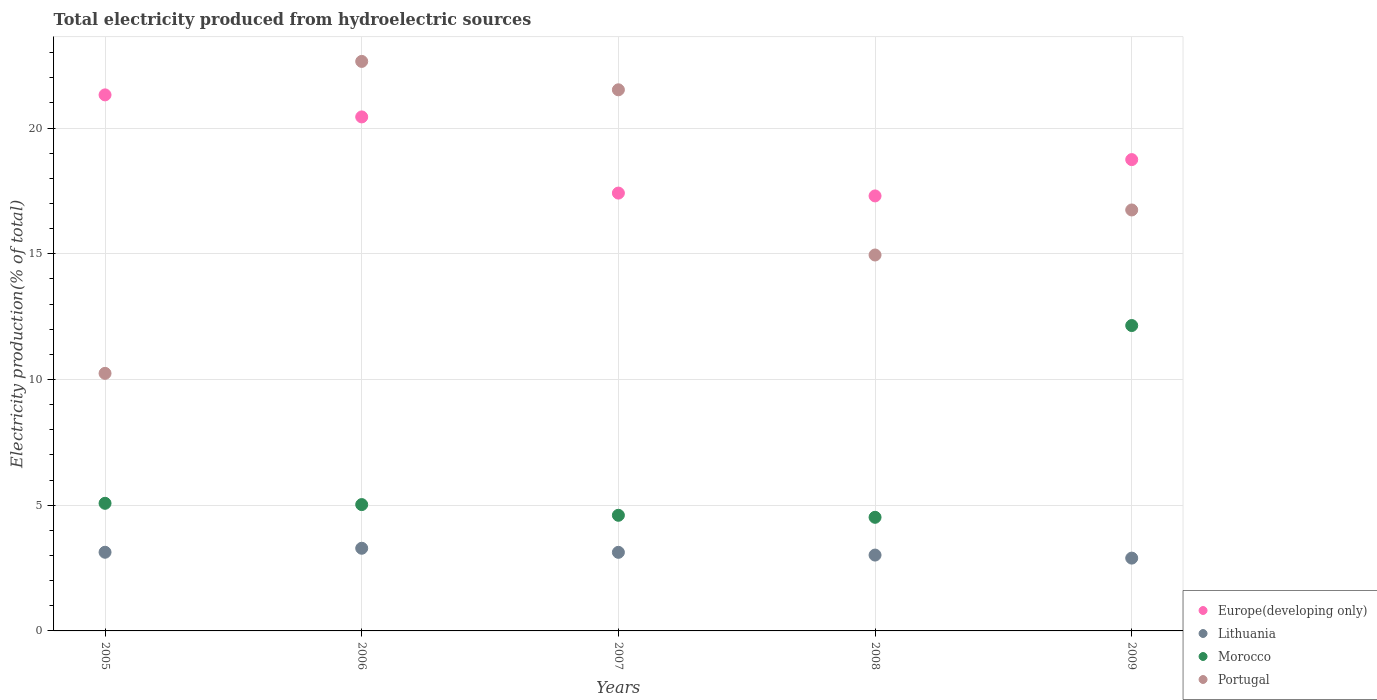How many different coloured dotlines are there?
Offer a very short reply. 4. What is the total electricity produced in Morocco in 2007?
Make the answer very short. 4.6. Across all years, what is the maximum total electricity produced in Portugal?
Give a very brief answer. 22.65. Across all years, what is the minimum total electricity produced in Lithuania?
Ensure brevity in your answer.  2.9. In which year was the total electricity produced in Europe(developing only) maximum?
Provide a short and direct response. 2005. What is the total total electricity produced in Lithuania in the graph?
Keep it short and to the point. 15.45. What is the difference between the total electricity produced in Europe(developing only) in 2007 and that in 2009?
Your answer should be very brief. -1.33. What is the difference between the total electricity produced in Portugal in 2006 and the total electricity produced in Europe(developing only) in 2005?
Keep it short and to the point. 1.33. What is the average total electricity produced in Portugal per year?
Offer a terse response. 17.22. In the year 2005, what is the difference between the total electricity produced in Lithuania and total electricity produced in Morocco?
Ensure brevity in your answer.  -1.95. In how many years, is the total electricity produced in Morocco greater than 3 %?
Your answer should be very brief. 5. What is the ratio of the total electricity produced in Morocco in 2005 to that in 2006?
Your answer should be compact. 1.01. Is the total electricity produced in Lithuania in 2005 less than that in 2009?
Your answer should be compact. No. Is the difference between the total electricity produced in Lithuania in 2005 and 2008 greater than the difference between the total electricity produced in Morocco in 2005 and 2008?
Ensure brevity in your answer.  No. What is the difference between the highest and the second highest total electricity produced in Europe(developing only)?
Your response must be concise. 0.88. What is the difference between the highest and the lowest total electricity produced in Lithuania?
Ensure brevity in your answer.  0.39. In how many years, is the total electricity produced in Morocco greater than the average total electricity produced in Morocco taken over all years?
Give a very brief answer. 1. Does the total electricity produced in Europe(developing only) monotonically increase over the years?
Keep it short and to the point. No. Is the total electricity produced in Portugal strictly greater than the total electricity produced in Europe(developing only) over the years?
Make the answer very short. No. How many dotlines are there?
Ensure brevity in your answer.  4. How many years are there in the graph?
Provide a short and direct response. 5. What is the difference between two consecutive major ticks on the Y-axis?
Offer a very short reply. 5. Where does the legend appear in the graph?
Provide a succinct answer. Bottom right. What is the title of the graph?
Give a very brief answer. Total electricity produced from hydroelectric sources. Does "Bhutan" appear as one of the legend labels in the graph?
Provide a short and direct response. No. What is the label or title of the X-axis?
Offer a very short reply. Years. What is the label or title of the Y-axis?
Your response must be concise. Electricity production(% of total). What is the Electricity production(% of total) of Europe(developing only) in 2005?
Provide a succinct answer. 21.32. What is the Electricity production(% of total) of Lithuania in 2005?
Ensure brevity in your answer.  3.13. What is the Electricity production(% of total) of Morocco in 2005?
Ensure brevity in your answer.  5.08. What is the Electricity production(% of total) of Portugal in 2005?
Provide a succinct answer. 10.24. What is the Electricity production(% of total) of Europe(developing only) in 2006?
Give a very brief answer. 20.44. What is the Electricity production(% of total) of Lithuania in 2006?
Provide a short and direct response. 3.29. What is the Electricity production(% of total) of Morocco in 2006?
Your answer should be compact. 5.02. What is the Electricity production(% of total) of Portugal in 2006?
Keep it short and to the point. 22.65. What is the Electricity production(% of total) in Europe(developing only) in 2007?
Ensure brevity in your answer.  17.41. What is the Electricity production(% of total) in Lithuania in 2007?
Offer a very short reply. 3.13. What is the Electricity production(% of total) in Morocco in 2007?
Keep it short and to the point. 4.6. What is the Electricity production(% of total) in Portugal in 2007?
Your answer should be compact. 21.52. What is the Electricity production(% of total) of Europe(developing only) in 2008?
Keep it short and to the point. 17.3. What is the Electricity production(% of total) of Lithuania in 2008?
Your response must be concise. 3.02. What is the Electricity production(% of total) in Morocco in 2008?
Provide a succinct answer. 4.52. What is the Electricity production(% of total) of Portugal in 2008?
Offer a very short reply. 14.95. What is the Electricity production(% of total) in Europe(developing only) in 2009?
Your answer should be very brief. 18.74. What is the Electricity production(% of total) of Lithuania in 2009?
Keep it short and to the point. 2.9. What is the Electricity production(% of total) of Morocco in 2009?
Offer a terse response. 12.14. What is the Electricity production(% of total) of Portugal in 2009?
Offer a terse response. 16.74. Across all years, what is the maximum Electricity production(% of total) in Europe(developing only)?
Provide a succinct answer. 21.32. Across all years, what is the maximum Electricity production(% of total) of Lithuania?
Give a very brief answer. 3.29. Across all years, what is the maximum Electricity production(% of total) of Morocco?
Your response must be concise. 12.14. Across all years, what is the maximum Electricity production(% of total) of Portugal?
Keep it short and to the point. 22.65. Across all years, what is the minimum Electricity production(% of total) of Europe(developing only)?
Ensure brevity in your answer.  17.3. Across all years, what is the minimum Electricity production(% of total) of Lithuania?
Your answer should be compact. 2.9. Across all years, what is the minimum Electricity production(% of total) in Morocco?
Provide a succinct answer. 4.52. Across all years, what is the minimum Electricity production(% of total) in Portugal?
Your response must be concise. 10.24. What is the total Electricity production(% of total) in Europe(developing only) in the graph?
Offer a very short reply. 95.22. What is the total Electricity production(% of total) in Lithuania in the graph?
Your answer should be very brief. 15.45. What is the total Electricity production(% of total) in Morocco in the graph?
Provide a short and direct response. 31.36. What is the total Electricity production(% of total) of Portugal in the graph?
Make the answer very short. 86.1. What is the difference between the Electricity production(% of total) of Europe(developing only) in 2005 and that in 2006?
Provide a succinct answer. 0.88. What is the difference between the Electricity production(% of total) of Lithuania in 2005 and that in 2006?
Make the answer very short. -0.16. What is the difference between the Electricity production(% of total) in Morocco in 2005 and that in 2006?
Your answer should be very brief. 0.05. What is the difference between the Electricity production(% of total) in Portugal in 2005 and that in 2006?
Offer a very short reply. -12.41. What is the difference between the Electricity production(% of total) of Europe(developing only) in 2005 and that in 2007?
Offer a terse response. 3.91. What is the difference between the Electricity production(% of total) in Lithuania in 2005 and that in 2007?
Make the answer very short. 0. What is the difference between the Electricity production(% of total) in Morocco in 2005 and that in 2007?
Provide a short and direct response. 0.48. What is the difference between the Electricity production(% of total) in Portugal in 2005 and that in 2007?
Give a very brief answer. -11.28. What is the difference between the Electricity production(% of total) of Europe(developing only) in 2005 and that in 2008?
Ensure brevity in your answer.  4.02. What is the difference between the Electricity production(% of total) of Lithuania in 2005 and that in 2008?
Give a very brief answer. 0.11. What is the difference between the Electricity production(% of total) in Morocco in 2005 and that in 2008?
Provide a short and direct response. 0.56. What is the difference between the Electricity production(% of total) of Portugal in 2005 and that in 2008?
Ensure brevity in your answer.  -4.71. What is the difference between the Electricity production(% of total) of Europe(developing only) in 2005 and that in 2009?
Provide a succinct answer. 2.57. What is the difference between the Electricity production(% of total) in Lithuania in 2005 and that in 2009?
Keep it short and to the point. 0.23. What is the difference between the Electricity production(% of total) of Morocco in 2005 and that in 2009?
Offer a very short reply. -7.07. What is the difference between the Electricity production(% of total) in Portugal in 2005 and that in 2009?
Ensure brevity in your answer.  -6.5. What is the difference between the Electricity production(% of total) of Europe(developing only) in 2006 and that in 2007?
Offer a terse response. 3.03. What is the difference between the Electricity production(% of total) of Lithuania in 2006 and that in 2007?
Offer a very short reply. 0.16. What is the difference between the Electricity production(% of total) in Morocco in 2006 and that in 2007?
Your answer should be compact. 0.43. What is the difference between the Electricity production(% of total) in Portugal in 2006 and that in 2007?
Ensure brevity in your answer.  1.13. What is the difference between the Electricity production(% of total) in Europe(developing only) in 2006 and that in 2008?
Ensure brevity in your answer.  3.14. What is the difference between the Electricity production(% of total) in Lithuania in 2006 and that in 2008?
Offer a terse response. 0.27. What is the difference between the Electricity production(% of total) in Morocco in 2006 and that in 2008?
Your answer should be very brief. 0.51. What is the difference between the Electricity production(% of total) in Portugal in 2006 and that in 2008?
Provide a succinct answer. 7.7. What is the difference between the Electricity production(% of total) of Europe(developing only) in 2006 and that in 2009?
Give a very brief answer. 1.7. What is the difference between the Electricity production(% of total) in Lithuania in 2006 and that in 2009?
Your response must be concise. 0.39. What is the difference between the Electricity production(% of total) of Morocco in 2006 and that in 2009?
Make the answer very short. -7.12. What is the difference between the Electricity production(% of total) in Portugal in 2006 and that in 2009?
Give a very brief answer. 5.91. What is the difference between the Electricity production(% of total) in Europe(developing only) in 2007 and that in 2008?
Your answer should be very brief. 0.11. What is the difference between the Electricity production(% of total) in Lithuania in 2007 and that in 2008?
Ensure brevity in your answer.  0.11. What is the difference between the Electricity production(% of total) of Morocco in 2007 and that in 2008?
Your answer should be very brief. 0.08. What is the difference between the Electricity production(% of total) in Portugal in 2007 and that in 2008?
Make the answer very short. 6.57. What is the difference between the Electricity production(% of total) of Europe(developing only) in 2007 and that in 2009?
Keep it short and to the point. -1.33. What is the difference between the Electricity production(% of total) of Lithuania in 2007 and that in 2009?
Make the answer very short. 0.23. What is the difference between the Electricity production(% of total) of Morocco in 2007 and that in 2009?
Keep it short and to the point. -7.55. What is the difference between the Electricity production(% of total) of Portugal in 2007 and that in 2009?
Your answer should be very brief. 4.78. What is the difference between the Electricity production(% of total) of Europe(developing only) in 2008 and that in 2009?
Provide a short and direct response. -1.44. What is the difference between the Electricity production(% of total) in Lithuania in 2008 and that in 2009?
Keep it short and to the point. 0.12. What is the difference between the Electricity production(% of total) of Morocco in 2008 and that in 2009?
Offer a terse response. -7.63. What is the difference between the Electricity production(% of total) of Portugal in 2008 and that in 2009?
Provide a short and direct response. -1.79. What is the difference between the Electricity production(% of total) in Europe(developing only) in 2005 and the Electricity production(% of total) in Lithuania in 2006?
Provide a short and direct response. 18.03. What is the difference between the Electricity production(% of total) in Europe(developing only) in 2005 and the Electricity production(% of total) in Morocco in 2006?
Your response must be concise. 16.29. What is the difference between the Electricity production(% of total) of Europe(developing only) in 2005 and the Electricity production(% of total) of Portugal in 2006?
Give a very brief answer. -1.33. What is the difference between the Electricity production(% of total) of Lithuania in 2005 and the Electricity production(% of total) of Morocco in 2006?
Ensure brevity in your answer.  -1.9. What is the difference between the Electricity production(% of total) of Lithuania in 2005 and the Electricity production(% of total) of Portugal in 2006?
Make the answer very short. -19.52. What is the difference between the Electricity production(% of total) in Morocco in 2005 and the Electricity production(% of total) in Portugal in 2006?
Your response must be concise. -17.57. What is the difference between the Electricity production(% of total) in Europe(developing only) in 2005 and the Electricity production(% of total) in Lithuania in 2007?
Ensure brevity in your answer.  18.19. What is the difference between the Electricity production(% of total) in Europe(developing only) in 2005 and the Electricity production(% of total) in Morocco in 2007?
Give a very brief answer. 16.72. What is the difference between the Electricity production(% of total) in Europe(developing only) in 2005 and the Electricity production(% of total) in Portugal in 2007?
Provide a succinct answer. -0.2. What is the difference between the Electricity production(% of total) of Lithuania in 2005 and the Electricity production(% of total) of Morocco in 2007?
Ensure brevity in your answer.  -1.47. What is the difference between the Electricity production(% of total) in Lithuania in 2005 and the Electricity production(% of total) in Portugal in 2007?
Provide a succinct answer. -18.39. What is the difference between the Electricity production(% of total) of Morocco in 2005 and the Electricity production(% of total) of Portugal in 2007?
Keep it short and to the point. -16.44. What is the difference between the Electricity production(% of total) in Europe(developing only) in 2005 and the Electricity production(% of total) in Lithuania in 2008?
Provide a short and direct response. 18.3. What is the difference between the Electricity production(% of total) in Europe(developing only) in 2005 and the Electricity production(% of total) in Morocco in 2008?
Offer a terse response. 16.8. What is the difference between the Electricity production(% of total) of Europe(developing only) in 2005 and the Electricity production(% of total) of Portugal in 2008?
Ensure brevity in your answer.  6.37. What is the difference between the Electricity production(% of total) in Lithuania in 2005 and the Electricity production(% of total) in Morocco in 2008?
Offer a terse response. -1.39. What is the difference between the Electricity production(% of total) of Lithuania in 2005 and the Electricity production(% of total) of Portugal in 2008?
Keep it short and to the point. -11.82. What is the difference between the Electricity production(% of total) of Morocco in 2005 and the Electricity production(% of total) of Portugal in 2008?
Offer a terse response. -9.88. What is the difference between the Electricity production(% of total) in Europe(developing only) in 2005 and the Electricity production(% of total) in Lithuania in 2009?
Ensure brevity in your answer.  18.42. What is the difference between the Electricity production(% of total) in Europe(developing only) in 2005 and the Electricity production(% of total) in Morocco in 2009?
Give a very brief answer. 9.17. What is the difference between the Electricity production(% of total) of Europe(developing only) in 2005 and the Electricity production(% of total) of Portugal in 2009?
Provide a succinct answer. 4.58. What is the difference between the Electricity production(% of total) of Lithuania in 2005 and the Electricity production(% of total) of Morocco in 2009?
Offer a terse response. -9.02. What is the difference between the Electricity production(% of total) in Lithuania in 2005 and the Electricity production(% of total) in Portugal in 2009?
Offer a terse response. -13.61. What is the difference between the Electricity production(% of total) of Morocco in 2005 and the Electricity production(% of total) of Portugal in 2009?
Keep it short and to the point. -11.67. What is the difference between the Electricity production(% of total) of Europe(developing only) in 2006 and the Electricity production(% of total) of Lithuania in 2007?
Keep it short and to the point. 17.32. What is the difference between the Electricity production(% of total) in Europe(developing only) in 2006 and the Electricity production(% of total) in Morocco in 2007?
Offer a very short reply. 15.84. What is the difference between the Electricity production(% of total) in Europe(developing only) in 2006 and the Electricity production(% of total) in Portugal in 2007?
Your answer should be compact. -1.08. What is the difference between the Electricity production(% of total) of Lithuania in 2006 and the Electricity production(% of total) of Morocco in 2007?
Provide a short and direct response. -1.31. What is the difference between the Electricity production(% of total) of Lithuania in 2006 and the Electricity production(% of total) of Portugal in 2007?
Your answer should be very brief. -18.23. What is the difference between the Electricity production(% of total) of Morocco in 2006 and the Electricity production(% of total) of Portugal in 2007?
Ensure brevity in your answer.  -16.5. What is the difference between the Electricity production(% of total) in Europe(developing only) in 2006 and the Electricity production(% of total) in Lithuania in 2008?
Keep it short and to the point. 17.43. What is the difference between the Electricity production(% of total) of Europe(developing only) in 2006 and the Electricity production(% of total) of Morocco in 2008?
Your answer should be compact. 15.92. What is the difference between the Electricity production(% of total) in Europe(developing only) in 2006 and the Electricity production(% of total) in Portugal in 2008?
Your answer should be compact. 5.49. What is the difference between the Electricity production(% of total) of Lithuania in 2006 and the Electricity production(% of total) of Morocco in 2008?
Provide a succinct answer. -1.23. What is the difference between the Electricity production(% of total) in Lithuania in 2006 and the Electricity production(% of total) in Portugal in 2008?
Keep it short and to the point. -11.66. What is the difference between the Electricity production(% of total) in Morocco in 2006 and the Electricity production(% of total) in Portugal in 2008?
Provide a short and direct response. -9.93. What is the difference between the Electricity production(% of total) in Europe(developing only) in 2006 and the Electricity production(% of total) in Lithuania in 2009?
Offer a terse response. 17.55. What is the difference between the Electricity production(% of total) of Europe(developing only) in 2006 and the Electricity production(% of total) of Morocco in 2009?
Provide a succinct answer. 8.3. What is the difference between the Electricity production(% of total) in Europe(developing only) in 2006 and the Electricity production(% of total) in Portugal in 2009?
Offer a very short reply. 3.7. What is the difference between the Electricity production(% of total) of Lithuania in 2006 and the Electricity production(% of total) of Morocco in 2009?
Make the answer very short. -8.86. What is the difference between the Electricity production(% of total) of Lithuania in 2006 and the Electricity production(% of total) of Portugal in 2009?
Ensure brevity in your answer.  -13.45. What is the difference between the Electricity production(% of total) in Morocco in 2006 and the Electricity production(% of total) in Portugal in 2009?
Your answer should be very brief. -11.72. What is the difference between the Electricity production(% of total) in Europe(developing only) in 2007 and the Electricity production(% of total) in Lithuania in 2008?
Provide a succinct answer. 14.4. What is the difference between the Electricity production(% of total) in Europe(developing only) in 2007 and the Electricity production(% of total) in Morocco in 2008?
Ensure brevity in your answer.  12.89. What is the difference between the Electricity production(% of total) of Europe(developing only) in 2007 and the Electricity production(% of total) of Portugal in 2008?
Provide a short and direct response. 2.46. What is the difference between the Electricity production(% of total) of Lithuania in 2007 and the Electricity production(% of total) of Morocco in 2008?
Offer a very short reply. -1.39. What is the difference between the Electricity production(% of total) in Lithuania in 2007 and the Electricity production(% of total) in Portugal in 2008?
Your response must be concise. -11.82. What is the difference between the Electricity production(% of total) of Morocco in 2007 and the Electricity production(% of total) of Portugal in 2008?
Provide a short and direct response. -10.35. What is the difference between the Electricity production(% of total) in Europe(developing only) in 2007 and the Electricity production(% of total) in Lithuania in 2009?
Provide a short and direct response. 14.52. What is the difference between the Electricity production(% of total) in Europe(developing only) in 2007 and the Electricity production(% of total) in Morocco in 2009?
Your response must be concise. 5.27. What is the difference between the Electricity production(% of total) of Europe(developing only) in 2007 and the Electricity production(% of total) of Portugal in 2009?
Provide a short and direct response. 0.67. What is the difference between the Electricity production(% of total) in Lithuania in 2007 and the Electricity production(% of total) in Morocco in 2009?
Provide a short and direct response. -9.02. What is the difference between the Electricity production(% of total) in Lithuania in 2007 and the Electricity production(% of total) in Portugal in 2009?
Your answer should be compact. -13.62. What is the difference between the Electricity production(% of total) of Morocco in 2007 and the Electricity production(% of total) of Portugal in 2009?
Provide a succinct answer. -12.14. What is the difference between the Electricity production(% of total) in Europe(developing only) in 2008 and the Electricity production(% of total) in Lithuania in 2009?
Your answer should be very brief. 14.4. What is the difference between the Electricity production(% of total) in Europe(developing only) in 2008 and the Electricity production(% of total) in Morocco in 2009?
Make the answer very short. 5.16. What is the difference between the Electricity production(% of total) of Europe(developing only) in 2008 and the Electricity production(% of total) of Portugal in 2009?
Give a very brief answer. 0.56. What is the difference between the Electricity production(% of total) of Lithuania in 2008 and the Electricity production(% of total) of Morocco in 2009?
Offer a terse response. -9.13. What is the difference between the Electricity production(% of total) in Lithuania in 2008 and the Electricity production(% of total) in Portugal in 2009?
Give a very brief answer. -13.72. What is the difference between the Electricity production(% of total) in Morocco in 2008 and the Electricity production(% of total) in Portugal in 2009?
Give a very brief answer. -12.22. What is the average Electricity production(% of total) of Europe(developing only) per year?
Your answer should be compact. 19.04. What is the average Electricity production(% of total) of Lithuania per year?
Give a very brief answer. 3.09. What is the average Electricity production(% of total) of Morocco per year?
Make the answer very short. 6.27. What is the average Electricity production(% of total) in Portugal per year?
Provide a short and direct response. 17.22. In the year 2005, what is the difference between the Electricity production(% of total) in Europe(developing only) and Electricity production(% of total) in Lithuania?
Offer a very short reply. 18.19. In the year 2005, what is the difference between the Electricity production(% of total) in Europe(developing only) and Electricity production(% of total) in Morocco?
Offer a terse response. 16.24. In the year 2005, what is the difference between the Electricity production(% of total) of Europe(developing only) and Electricity production(% of total) of Portugal?
Your answer should be very brief. 11.07. In the year 2005, what is the difference between the Electricity production(% of total) of Lithuania and Electricity production(% of total) of Morocco?
Ensure brevity in your answer.  -1.95. In the year 2005, what is the difference between the Electricity production(% of total) in Lithuania and Electricity production(% of total) in Portugal?
Keep it short and to the point. -7.11. In the year 2005, what is the difference between the Electricity production(% of total) in Morocco and Electricity production(% of total) in Portugal?
Provide a succinct answer. -5.17. In the year 2006, what is the difference between the Electricity production(% of total) in Europe(developing only) and Electricity production(% of total) in Lithuania?
Offer a terse response. 17.15. In the year 2006, what is the difference between the Electricity production(% of total) of Europe(developing only) and Electricity production(% of total) of Morocco?
Ensure brevity in your answer.  15.42. In the year 2006, what is the difference between the Electricity production(% of total) in Europe(developing only) and Electricity production(% of total) in Portugal?
Your answer should be compact. -2.21. In the year 2006, what is the difference between the Electricity production(% of total) in Lithuania and Electricity production(% of total) in Morocco?
Provide a succinct answer. -1.74. In the year 2006, what is the difference between the Electricity production(% of total) in Lithuania and Electricity production(% of total) in Portugal?
Offer a very short reply. -19.36. In the year 2006, what is the difference between the Electricity production(% of total) in Morocco and Electricity production(% of total) in Portugal?
Provide a short and direct response. -17.62. In the year 2007, what is the difference between the Electricity production(% of total) of Europe(developing only) and Electricity production(% of total) of Lithuania?
Your answer should be very brief. 14.29. In the year 2007, what is the difference between the Electricity production(% of total) in Europe(developing only) and Electricity production(% of total) in Morocco?
Make the answer very short. 12.81. In the year 2007, what is the difference between the Electricity production(% of total) of Europe(developing only) and Electricity production(% of total) of Portugal?
Provide a succinct answer. -4.11. In the year 2007, what is the difference between the Electricity production(% of total) of Lithuania and Electricity production(% of total) of Morocco?
Offer a terse response. -1.47. In the year 2007, what is the difference between the Electricity production(% of total) in Lithuania and Electricity production(% of total) in Portugal?
Make the answer very short. -18.39. In the year 2007, what is the difference between the Electricity production(% of total) in Morocco and Electricity production(% of total) in Portugal?
Ensure brevity in your answer.  -16.92. In the year 2008, what is the difference between the Electricity production(% of total) in Europe(developing only) and Electricity production(% of total) in Lithuania?
Offer a terse response. 14.28. In the year 2008, what is the difference between the Electricity production(% of total) of Europe(developing only) and Electricity production(% of total) of Morocco?
Your answer should be very brief. 12.78. In the year 2008, what is the difference between the Electricity production(% of total) of Europe(developing only) and Electricity production(% of total) of Portugal?
Your answer should be compact. 2.35. In the year 2008, what is the difference between the Electricity production(% of total) of Lithuania and Electricity production(% of total) of Morocco?
Provide a short and direct response. -1.5. In the year 2008, what is the difference between the Electricity production(% of total) of Lithuania and Electricity production(% of total) of Portugal?
Make the answer very short. -11.93. In the year 2008, what is the difference between the Electricity production(% of total) in Morocco and Electricity production(% of total) in Portugal?
Your answer should be very brief. -10.43. In the year 2009, what is the difference between the Electricity production(% of total) in Europe(developing only) and Electricity production(% of total) in Lithuania?
Offer a terse response. 15.85. In the year 2009, what is the difference between the Electricity production(% of total) in Europe(developing only) and Electricity production(% of total) in Morocco?
Your answer should be very brief. 6.6. In the year 2009, what is the difference between the Electricity production(% of total) in Europe(developing only) and Electricity production(% of total) in Portugal?
Offer a terse response. 2. In the year 2009, what is the difference between the Electricity production(% of total) in Lithuania and Electricity production(% of total) in Morocco?
Your response must be concise. -9.25. In the year 2009, what is the difference between the Electricity production(% of total) in Lithuania and Electricity production(% of total) in Portugal?
Your answer should be very brief. -13.85. In the year 2009, what is the difference between the Electricity production(% of total) of Morocco and Electricity production(% of total) of Portugal?
Ensure brevity in your answer.  -4.6. What is the ratio of the Electricity production(% of total) in Europe(developing only) in 2005 to that in 2006?
Give a very brief answer. 1.04. What is the ratio of the Electricity production(% of total) in Lithuania in 2005 to that in 2006?
Offer a terse response. 0.95. What is the ratio of the Electricity production(% of total) of Morocco in 2005 to that in 2006?
Keep it short and to the point. 1.01. What is the ratio of the Electricity production(% of total) in Portugal in 2005 to that in 2006?
Ensure brevity in your answer.  0.45. What is the ratio of the Electricity production(% of total) in Europe(developing only) in 2005 to that in 2007?
Your response must be concise. 1.22. What is the ratio of the Electricity production(% of total) of Morocco in 2005 to that in 2007?
Your response must be concise. 1.1. What is the ratio of the Electricity production(% of total) of Portugal in 2005 to that in 2007?
Give a very brief answer. 0.48. What is the ratio of the Electricity production(% of total) in Europe(developing only) in 2005 to that in 2008?
Keep it short and to the point. 1.23. What is the ratio of the Electricity production(% of total) in Lithuania in 2005 to that in 2008?
Keep it short and to the point. 1.04. What is the ratio of the Electricity production(% of total) of Morocco in 2005 to that in 2008?
Your answer should be compact. 1.12. What is the ratio of the Electricity production(% of total) of Portugal in 2005 to that in 2008?
Provide a short and direct response. 0.69. What is the ratio of the Electricity production(% of total) of Europe(developing only) in 2005 to that in 2009?
Offer a terse response. 1.14. What is the ratio of the Electricity production(% of total) in Lithuania in 2005 to that in 2009?
Offer a terse response. 1.08. What is the ratio of the Electricity production(% of total) in Morocco in 2005 to that in 2009?
Offer a terse response. 0.42. What is the ratio of the Electricity production(% of total) in Portugal in 2005 to that in 2009?
Offer a very short reply. 0.61. What is the ratio of the Electricity production(% of total) in Europe(developing only) in 2006 to that in 2007?
Your answer should be very brief. 1.17. What is the ratio of the Electricity production(% of total) in Lithuania in 2006 to that in 2007?
Provide a succinct answer. 1.05. What is the ratio of the Electricity production(% of total) of Morocco in 2006 to that in 2007?
Provide a short and direct response. 1.09. What is the ratio of the Electricity production(% of total) of Portugal in 2006 to that in 2007?
Ensure brevity in your answer.  1.05. What is the ratio of the Electricity production(% of total) in Europe(developing only) in 2006 to that in 2008?
Your answer should be very brief. 1.18. What is the ratio of the Electricity production(% of total) of Lithuania in 2006 to that in 2008?
Keep it short and to the point. 1.09. What is the ratio of the Electricity production(% of total) in Morocco in 2006 to that in 2008?
Your response must be concise. 1.11. What is the ratio of the Electricity production(% of total) of Portugal in 2006 to that in 2008?
Make the answer very short. 1.51. What is the ratio of the Electricity production(% of total) of Europe(developing only) in 2006 to that in 2009?
Offer a terse response. 1.09. What is the ratio of the Electricity production(% of total) of Lithuania in 2006 to that in 2009?
Provide a succinct answer. 1.14. What is the ratio of the Electricity production(% of total) of Morocco in 2006 to that in 2009?
Your answer should be very brief. 0.41. What is the ratio of the Electricity production(% of total) of Portugal in 2006 to that in 2009?
Provide a short and direct response. 1.35. What is the ratio of the Electricity production(% of total) in Europe(developing only) in 2007 to that in 2008?
Offer a very short reply. 1.01. What is the ratio of the Electricity production(% of total) in Lithuania in 2007 to that in 2008?
Your response must be concise. 1.04. What is the ratio of the Electricity production(% of total) of Morocco in 2007 to that in 2008?
Your response must be concise. 1.02. What is the ratio of the Electricity production(% of total) in Portugal in 2007 to that in 2008?
Your answer should be very brief. 1.44. What is the ratio of the Electricity production(% of total) of Europe(developing only) in 2007 to that in 2009?
Your answer should be compact. 0.93. What is the ratio of the Electricity production(% of total) in Lithuania in 2007 to that in 2009?
Provide a short and direct response. 1.08. What is the ratio of the Electricity production(% of total) in Morocco in 2007 to that in 2009?
Offer a terse response. 0.38. What is the ratio of the Electricity production(% of total) in Portugal in 2007 to that in 2009?
Your answer should be very brief. 1.29. What is the ratio of the Electricity production(% of total) of Europe(developing only) in 2008 to that in 2009?
Offer a terse response. 0.92. What is the ratio of the Electricity production(% of total) of Lithuania in 2008 to that in 2009?
Keep it short and to the point. 1.04. What is the ratio of the Electricity production(% of total) of Morocco in 2008 to that in 2009?
Ensure brevity in your answer.  0.37. What is the ratio of the Electricity production(% of total) in Portugal in 2008 to that in 2009?
Make the answer very short. 0.89. What is the difference between the highest and the second highest Electricity production(% of total) of Europe(developing only)?
Provide a short and direct response. 0.88. What is the difference between the highest and the second highest Electricity production(% of total) of Lithuania?
Provide a short and direct response. 0.16. What is the difference between the highest and the second highest Electricity production(% of total) in Morocco?
Make the answer very short. 7.07. What is the difference between the highest and the second highest Electricity production(% of total) in Portugal?
Provide a succinct answer. 1.13. What is the difference between the highest and the lowest Electricity production(% of total) of Europe(developing only)?
Make the answer very short. 4.02. What is the difference between the highest and the lowest Electricity production(% of total) in Lithuania?
Give a very brief answer. 0.39. What is the difference between the highest and the lowest Electricity production(% of total) in Morocco?
Offer a terse response. 7.63. What is the difference between the highest and the lowest Electricity production(% of total) in Portugal?
Your answer should be very brief. 12.41. 